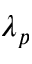<formula> <loc_0><loc_0><loc_500><loc_500>\lambda _ { p }</formula> 